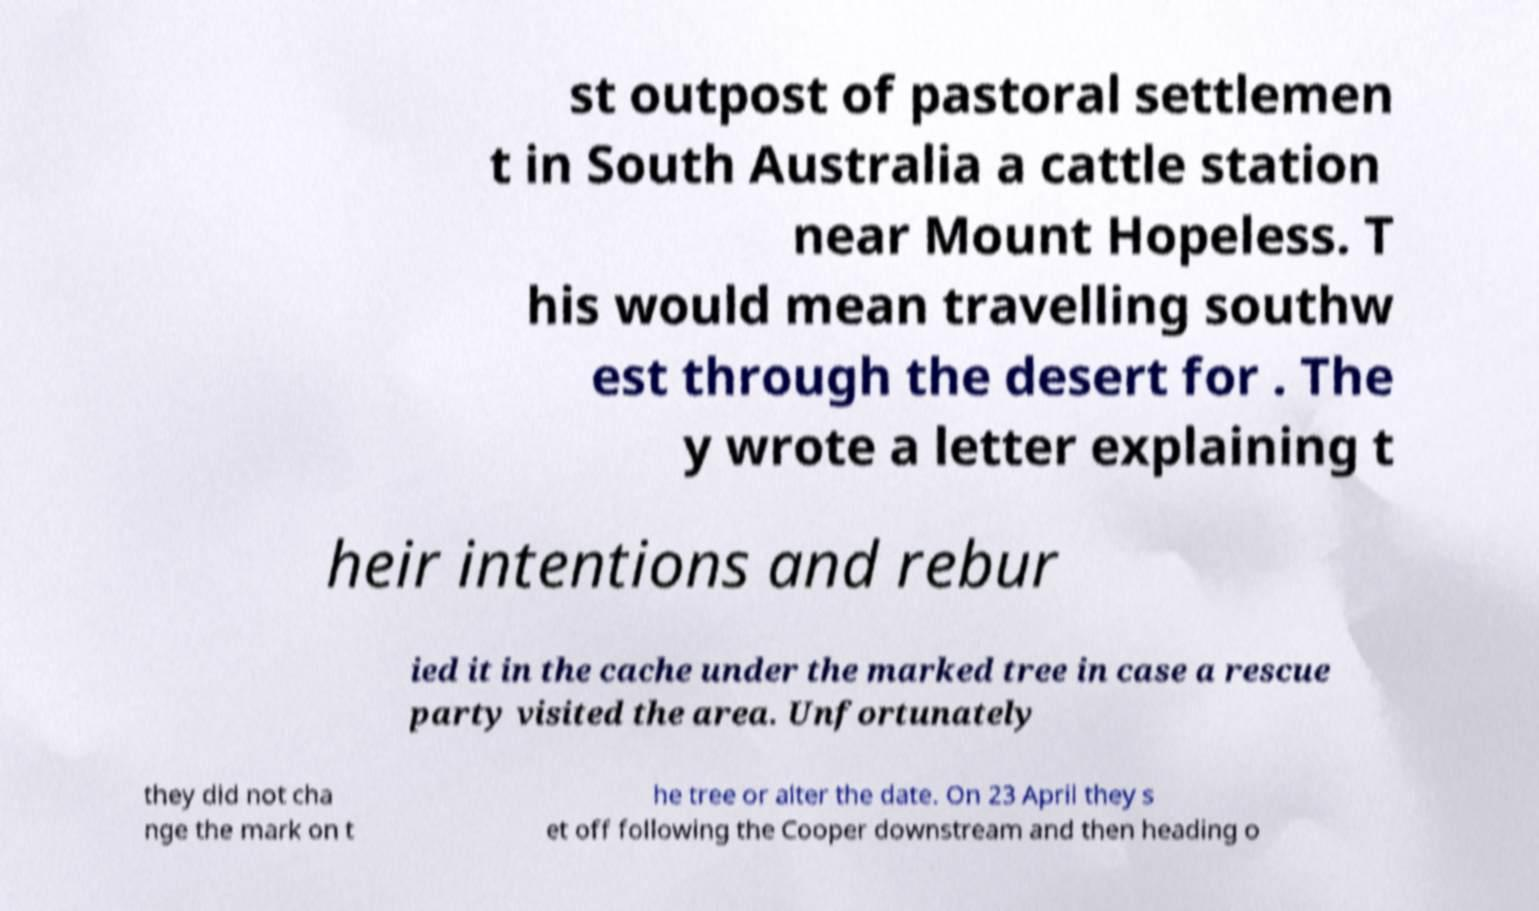What messages or text are displayed in this image? I need them in a readable, typed format. st outpost of pastoral settlemen t in South Australia a cattle station near Mount Hopeless. T his would mean travelling southw est through the desert for . The y wrote a letter explaining t heir intentions and rebur ied it in the cache under the marked tree in case a rescue party visited the area. Unfortunately they did not cha nge the mark on t he tree or alter the date. On 23 April they s et off following the Cooper downstream and then heading o 